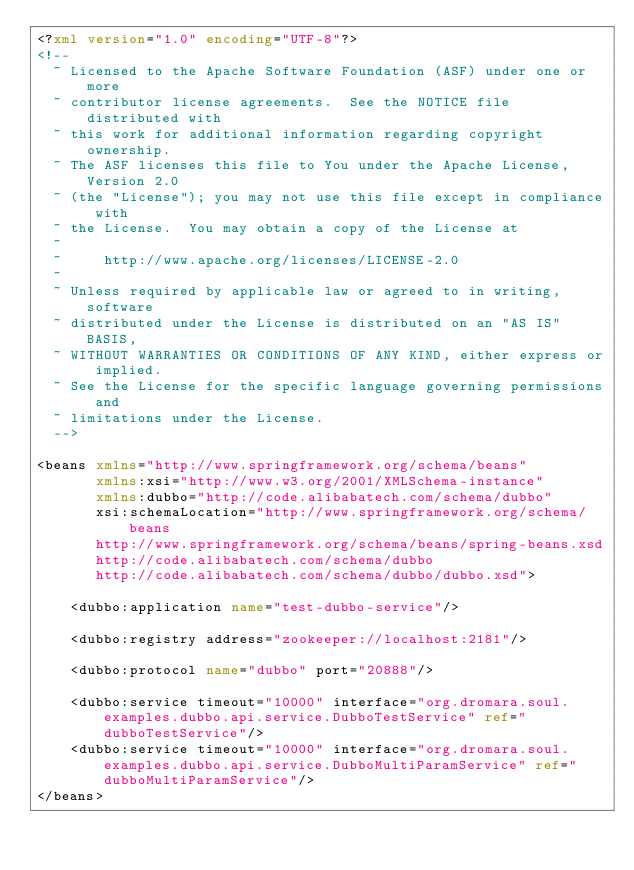<code> <loc_0><loc_0><loc_500><loc_500><_XML_><?xml version="1.0" encoding="UTF-8"?>
<!--
  ~ Licensed to the Apache Software Foundation (ASF) under one or more
  ~ contributor license agreements.  See the NOTICE file distributed with
  ~ this work for additional information regarding copyright ownership.
  ~ The ASF licenses this file to You under the Apache License, Version 2.0
  ~ (the "License"); you may not use this file except in compliance with
  ~ the License.  You may obtain a copy of the License at
  ~
  ~     http://www.apache.org/licenses/LICENSE-2.0
  ~
  ~ Unless required by applicable law or agreed to in writing, software
  ~ distributed under the License is distributed on an "AS IS" BASIS,
  ~ WITHOUT WARRANTIES OR CONDITIONS OF ANY KIND, either express or implied.
  ~ See the License for the specific language governing permissions and
  ~ limitations under the License.
  -->

<beans xmlns="http://www.springframework.org/schema/beans"
       xmlns:xsi="http://www.w3.org/2001/XMLSchema-instance"
       xmlns:dubbo="http://code.alibabatech.com/schema/dubbo"
       xsi:schemaLocation="http://www.springframework.org/schema/beans
       http://www.springframework.org/schema/beans/spring-beans.xsd
       http://code.alibabatech.com/schema/dubbo
       http://code.alibabatech.com/schema/dubbo/dubbo.xsd">

    <dubbo:application name="test-dubbo-service"/>

    <dubbo:registry address="zookeeper://localhost:2181"/>

    <dubbo:protocol name="dubbo" port="20888"/>

    <dubbo:service timeout="10000" interface="org.dromara.soul.examples.dubbo.api.service.DubboTestService" ref="dubboTestService"/>
    <dubbo:service timeout="10000" interface="org.dromara.soul.examples.dubbo.api.service.DubboMultiParamService" ref="dubboMultiParamService"/>
</beans>
</code> 